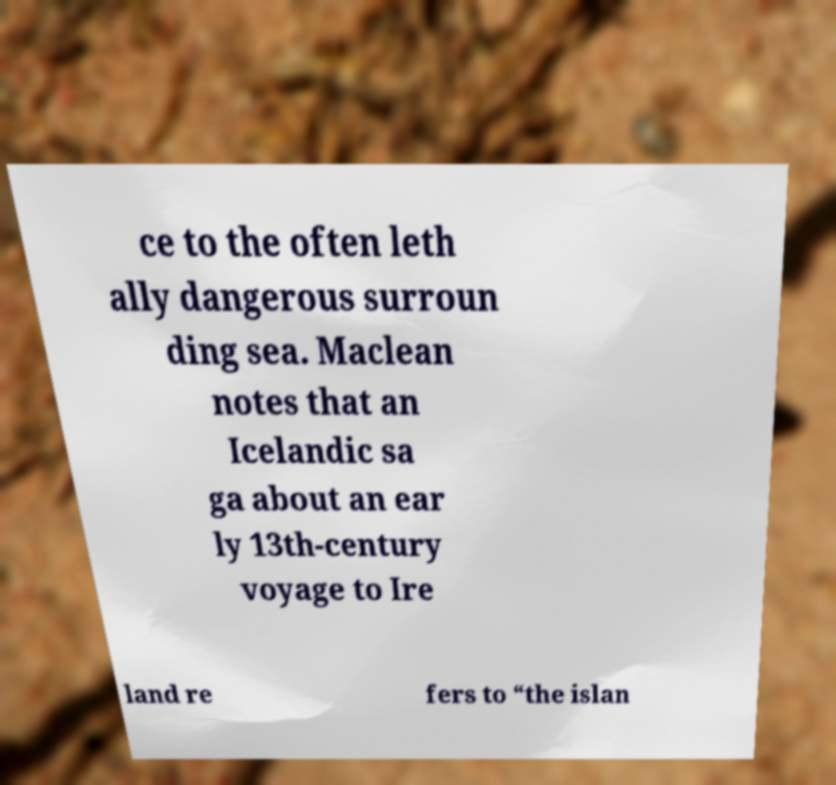Please identify and transcribe the text found in this image. ce to the often leth ally dangerous surroun ding sea. Maclean notes that an Icelandic sa ga about an ear ly 13th-century voyage to Ire land re fers to “the islan 